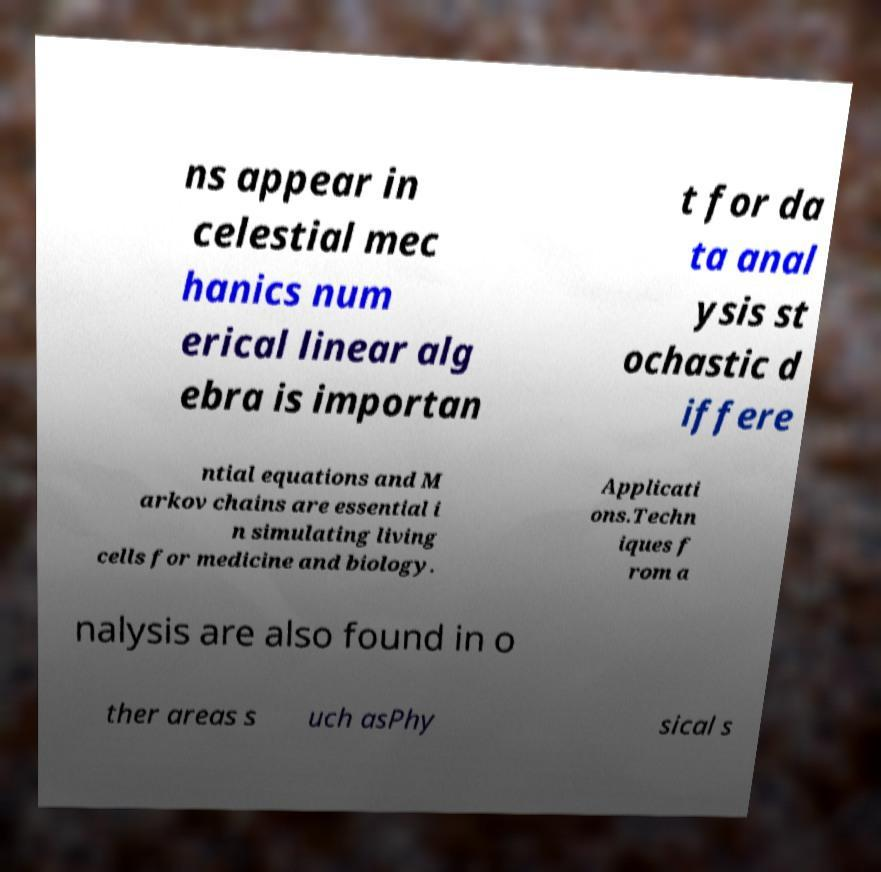I need the written content from this picture converted into text. Can you do that? ns appear in celestial mec hanics num erical linear alg ebra is importan t for da ta anal ysis st ochastic d iffere ntial equations and M arkov chains are essential i n simulating living cells for medicine and biology. Applicati ons.Techn iques f rom a nalysis are also found in o ther areas s uch asPhy sical s 